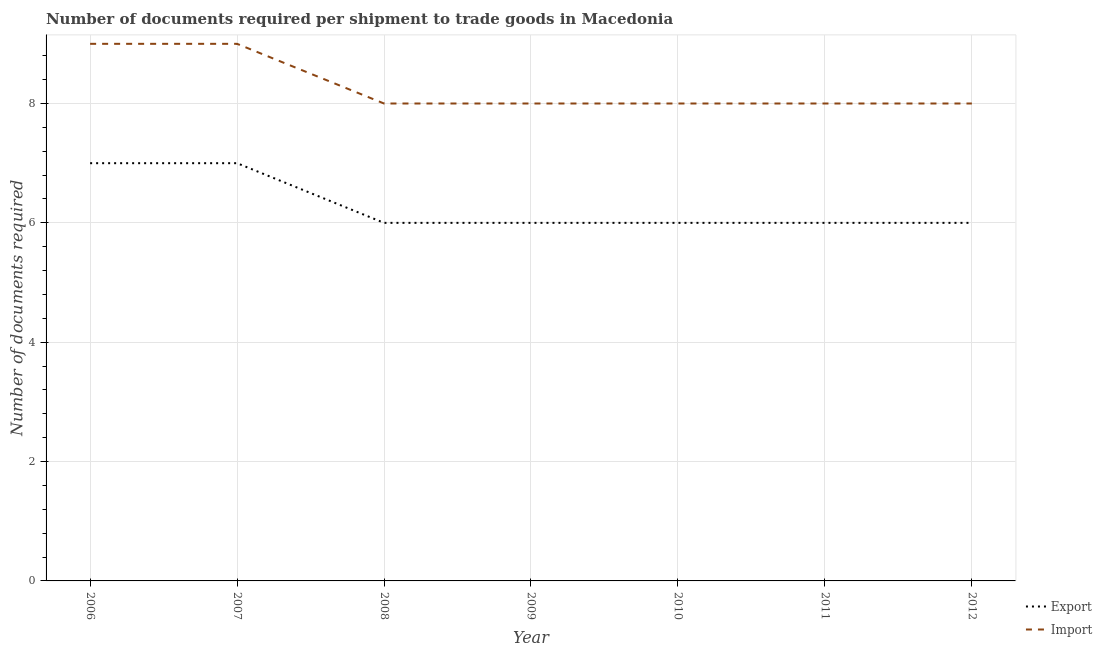Does the line corresponding to number of documents required to import goods intersect with the line corresponding to number of documents required to export goods?
Make the answer very short. No. What is the number of documents required to import goods in 2006?
Provide a short and direct response. 9. Across all years, what is the maximum number of documents required to import goods?
Your answer should be compact. 9. In which year was the number of documents required to export goods maximum?
Your response must be concise. 2006. In which year was the number of documents required to import goods minimum?
Offer a terse response. 2008. What is the total number of documents required to import goods in the graph?
Provide a short and direct response. 58. What is the difference between the number of documents required to export goods in 2007 and that in 2012?
Offer a very short reply. 1. What is the difference between the number of documents required to export goods in 2007 and the number of documents required to import goods in 2011?
Offer a terse response. -1. What is the average number of documents required to export goods per year?
Your answer should be very brief. 6.29. In the year 2008, what is the difference between the number of documents required to export goods and number of documents required to import goods?
Make the answer very short. -2. In how many years, is the number of documents required to export goods greater than 0.4?
Provide a succinct answer. 7. Is the number of documents required to import goods in 2007 less than that in 2009?
Give a very brief answer. No. Is the difference between the number of documents required to export goods in 2006 and 2012 greater than the difference between the number of documents required to import goods in 2006 and 2012?
Your answer should be very brief. No. What is the difference between the highest and the lowest number of documents required to export goods?
Your response must be concise. 1. In how many years, is the number of documents required to export goods greater than the average number of documents required to export goods taken over all years?
Offer a very short reply. 2. Is the sum of the number of documents required to export goods in 2006 and 2008 greater than the maximum number of documents required to import goods across all years?
Provide a succinct answer. Yes. Is the number of documents required to export goods strictly greater than the number of documents required to import goods over the years?
Offer a terse response. No. Is the number of documents required to import goods strictly less than the number of documents required to export goods over the years?
Your response must be concise. No. How many years are there in the graph?
Make the answer very short. 7. What is the difference between two consecutive major ticks on the Y-axis?
Give a very brief answer. 2. Are the values on the major ticks of Y-axis written in scientific E-notation?
Your answer should be very brief. No. Does the graph contain any zero values?
Ensure brevity in your answer.  No. Does the graph contain grids?
Provide a succinct answer. Yes. How many legend labels are there?
Ensure brevity in your answer.  2. How are the legend labels stacked?
Your answer should be very brief. Vertical. What is the title of the graph?
Give a very brief answer. Number of documents required per shipment to trade goods in Macedonia. What is the label or title of the X-axis?
Provide a succinct answer. Year. What is the label or title of the Y-axis?
Offer a very short reply. Number of documents required. What is the Number of documents required of Export in 2006?
Offer a terse response. 7. What is the Number of documents required of Export in 2007?
Your response must be concise. 7. What is the Number of documents required of Import in 2007?
Provide a succinct answer. 9. What is the Number of documents required in Export in 2008?
Your response must be concise. 6. What is the Number of documents required of Import in 2008?
Provide a succinct answer. 8. What is the Number of documents required in Import in 2010?
Your response must be concise. 8. What is the Number of documents required of Export in 2011?
Your answer should be very brief. 6. What is the Number of documents required of Import in 2011?
Make the answer very short. 8. What is the Number of documents required of Export in 2012?
Offer a very short reply. 6. What is the Number of documents required of Import in 2012?
Provide a short and direct response. 8. Across all years, what is the maximum Number of documents required of Export?
Offer a very short reply. 7. Across all years, what is the minimum Number of documents required of Export?
Give a very brief answer. 6. What is the total Number of documents required in Export in the graph?
Your answer should be compact. 44. What is the difference between the Number of documents required in Export in 2006 and that in 2007?
Your answer should be compact. 0. What is the difference between the Number of documents required of Import in 2006 and that in 2007?
Your answer should be compact. 0. What is the difference between the Number of documents required in Import in 2006 and that in 2010?
Your answer should be compact. 1. What is the difference between the Number of documents required in Export in 2006 and that in 2011?
Offer a very short reply. 1. What is the difference between the Number of documents required in Export in 2006 and that in 2012?
Give a very brief answer. 1. What is the difference between the Number of documents required of Import in 2006 and that in 2012?
Ensure brevity in your answer.  1. What is the difference between the Number of documents required of Export in 2007 and that in 2009?
Offer a terse response. 1. What is the difference between the Number of documents required of Import in 2007 and that in 2009?
Ensure brevity in your answer.  1. What is the difference between the Number of documents required in Import in 2007 and that in 2011?
Provide a succinct answer. 1. What is the difference between the Number of documents required in Export in 2007 and that in 2012?
Offer a very short reply. 1. What is the difference between the Number of documents required in Export in 2008 and that in 2009?
Give a very brief answer. 0. What is the difference between the Number of documents required in Import in 2008 and that in 2009?
Your answer should be very brief. 0. What is the difference between the Number of documents required in Import in 2008 and that in 2011?
Give a very brief answer. 0. What is the difference between the Number of documents required of Export in 2008 and that in 2012?
Ensure brevity in your answer.  0. What is the difference between the Number of documents required in Import in 2008 and that in 2012?
Keep it short and to the point. 0. What is the difference between the Number of documents required in Export in 2009 and that in 2010?
Make the answer very short. 0. What is the difference between the Number of documents required in Import in 2009 and that in 2010?
Keep it short and to the point. 0. What is the difference between the Number of documents required in Export in 2009 and that in 2012?
Ensure brevity in your answer.  0. What is the difference between the Number of documents required in Import in 2009 and that in 2012?
Ensure brevity in your answer.  0. What is the difference between the Number of documents required in Export in 2010 and that in 2011?
Offer a terse response. 0. What is the difference between the Number of documents required in Import in 2010 and that in 2011?
Make the answer very short. 0. What is the difference between the Number of documents required in Import in 2010 and that in 2012?
Provide a short and direct response. 0. What is the difference between the Number of documents required of Import in 2011 and that in 2012?
Provide a short and direct response. 0. What is the difference between the Number of documents required in Export in 2006 and the Number of documents required in Import in 2007?
Make the answer very short. -2. What is the difference between the Number of documents required of Export in 2006 and the Number of documents required of Import in 2009?
Provide a short and direct response. -1. What is the difference between the Number of documents required in Export in 2006 and the Number of documents required in Import in 2010?
Provide a short and direct response. -1. What is the difference between the Number of documents required of Export in 2007 and the Number of documents required of Import in 2011?
Keep it short and to the point. -1. What is the difference between the Number of documents required in Export in 2007 and the Number of documents required in Import in 2012?
Provide a succinct answer. -1. What is the difference between the Number of documents required of Export in 2008 and the Number of documents required of Import in 2009?
Offer a terse response. -2. What is the difference between the Number of documents required in Export in 2008 and the Number of documents required in Import in 2010?
Give a very brief answer. -2. What is the difference between the Number of documents required of Export in 2008 and the Number of documents required of Import in 2011?
Keep it short and to the point. -2. What is the difference between the Number of documents required in Export in 2009 and the Number of documents required in Import in 2012?
Offer a terse response. -2. What is the difference between the Number of documents required of Export in 2010 and the Number of documents required of Import in 2012?
Keep it short and to the point. -2. What is the average Number of documents required in Export per year?
Your answer should be very brief. 6.29. What is the average Number of documents required in Import per year?
Ensure brevity in your answer.  8.29. In the year 2006, what is the difference between the Number of documents required in Export and Number of documents required in Import?
Provide a short and direct response. -2. In the year 2007, what is the difference between the Number of documents required of Export and Number of documents required of Import?
Your response must be concise. -2. In the year 2009, what is the difference between the Number of documents required in Export and Number of documents required in Import?
Keep it short and to the point. -2. In the year 2011, what is the difference between the Number of documents required in Export and Number of documents required in Import?
Your answer should be very brief. -2. What is the ratio of the Number of documents required in Export in 2006 to that in 2007?
Ensure brevity in your answer.  1. What is the ratio of the Number of documents required of Import in 2006 to that in 2007?
Offer a very short reply. 1. What is the ratio of the Number of documents required in Export in 2006 to that in 2009?
Provide a short and direct response. 1.17. What is the ratio of the Number of documents required in Export in 2006 to that in 2010?
Your answer should be compact. 1.17. What is the ratio of the Number of documents required in Import in 2006 to that in 2010?
Offer a very short reply. 1.12. What is the ratio of the Number of documents required in Export in 2007 to that in 2008?
Make the answer very short. 1.17. What is the ratio of the Number of documents required of Import in 2007 to that in 2008?
Your answer should be compact. 1.12. What is the ratio of the Number of documents required of Import in 2007 to that in 2009?
Give a very brief answer. 1.12. What is the ratio of the Number of documents required of Import in 2007 to that in 2011?
Provide a succinct answer. 1.12. What is the ratio of the Number of documents required in Export in 2007 to that in 2012?
Provide a succinct answer. 1.17. What is the ratio of the Number of documents required of Import in 2007 to that in 2012?
Your answer should be very brief. 1.12. What is the ratio of the Number of documents required of Export in 2008 to that in 2009?
Provide a short and direct response. 1. What is the ratio of the Number of documents required of Import in 2008 to that in 2009?
Offer a terse response. 1. What is the ratio of the Number of documents required of Export in 2008 to that in 2010?
Your answer should be compact. 1. What is the ratio of the Number of documents required of Import in 2008 to that in 2010?
Your response must be concise. 1. What is the ratio of the Number of documents required in Export in 2008 to that in 2011?
Offer a very short reply. 1. What is the ratio of the Number of documents required of Export in 2009 to that in 2011?
Your answer should be compact. 1. What is the ratio of the Number of documents required in Export in 2009 to that in 2012?
Give a very brief answer. 1. What is the ratio of the Number of documents required of Export in 2010 to that in 2011?
Your response must be concise. 1. What is the ratio of the Number of documents required of Export in 2010 to that in 2012?
Offer a terse response. 1. What is the ratio of the Number of documents required of Export in 2011 to that in 2012?
Keep it short and to the point. 1. What is the difference between the highest and the second highest Number of documents required of Import?
Your response must be concise. 0. What is the difference between the highest and the lowest Number of documents required of Import?
Offer a terse response. 1. 